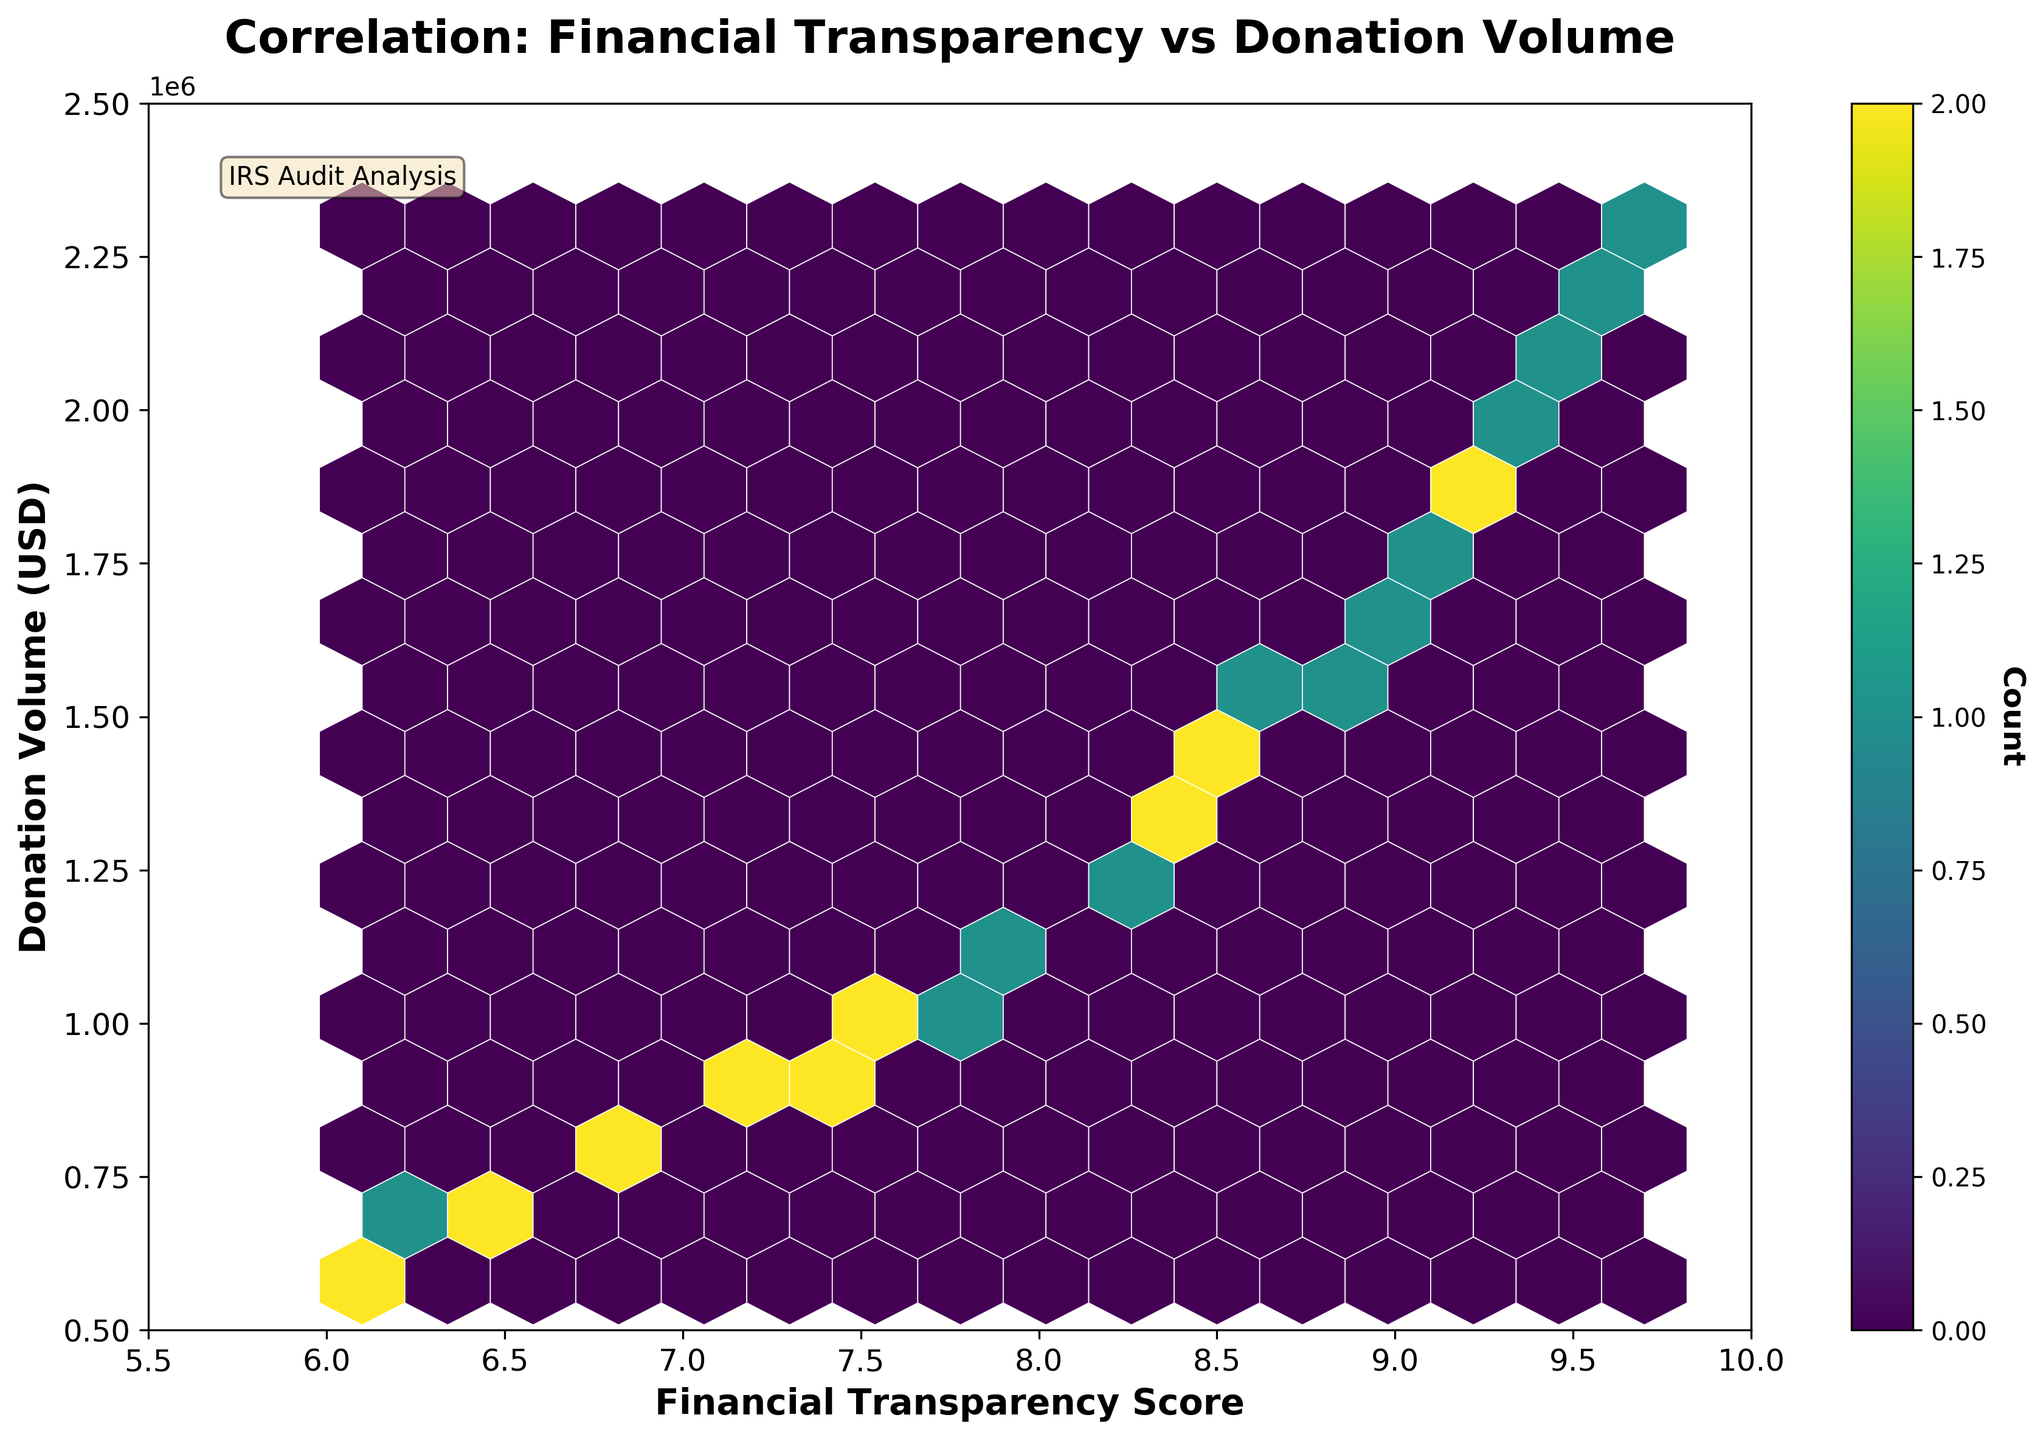What's the title of the figure? The title is displayed at the top of the plot and reads "Correlation: Financial Transparency vs Donation Volume."
Answer: Correlation: Financial Transparency vs Donation Volume What are the labels of the x and y axes? The x-axis label reads "Financial Transparency Score," and the y-axis label reads "Donation Volume (USD)."
Answer: Financial Transparency Score, Donation Volume (USD) What's the color indicating the highest density of data points? The highest density is shown with a yellowish color, seen in the color bar attached to the plot.
Answer: yellowish How many data points have a Financial Transparency Score above 9.0? Observing the highest density areas and count of hexagons, there are at least 7 visible data points above the score of 9.0.
Answer: 7 What's the range of the x-axis and y-axis? The x-axis ranges from 5.5 to 10, and the y-axis ranges from 500,000 to 2,500,000.
Answer: 5.5 to 10, 500,000 to 2,500,000 How does Donation Volume generally change as Financial Transparency Score increases? Observing the hexbin density and overall trend of hexagons moving upwards, as the Financial Transparency Score increases, the Donation Volume generally increases.
Answer: It increases Which transparency score shows the highest density of donations between 1,800,000 and 2,200,000 USD? The highest density in this donation volume range occurs around Financial Transparency Scores of approximately 9.2 to 9.6.
Answer: 9.2 to 9.6 Which score interval has the least donation volume under 1,000,000 USD? Observing the color density and distribution of hexagons, Financial Transparency Scores of approximately 6.1 to 6.5 have the least donation volume under 1,000,000 USD.
Answer: 6.1 to 6.5 Is there a distinct cluster of data points, and where is it located? There is a distinct cluster noted where higher financial transparency scores (above 9) reach donation volumes between 1,800,000 and 2,200,000 USD.
Answer: Above 9, between 1,800,000 and 2,200,000 USD 